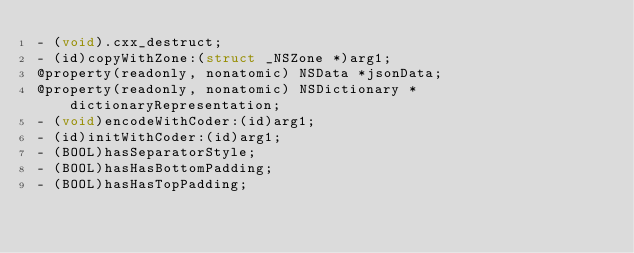<code> <loc_0><loc_0><loc_500><loc_500><_C_>- (void).cxx_destruct;
- (id)copyWithZone:(struct _NSZone *)arg1;
@property(readonly, nonatomic) NSData *jsonData;
@property(readonly, nonatomic) NSDictionary *dictionaryRepresentation;
- (void)encodeWithCoder:(id)arg1;
- (id)initWithCoder:(id)arg1;
- (BOOL)hasSeparatorStyle;
- (BOOL)hasHasBottomPadding;
- (BOOL)hasHasTopPadding;</code> 